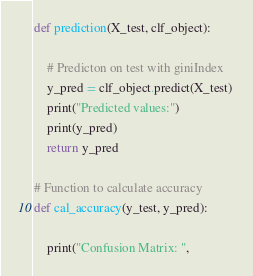<code> <loc_0><loc_0><loc_500><loc_500><_Python_>def prediction(X_test, clf_object): 

	# Predicton on test with giniIndex 
	y_pred = clf_object.predict(X_test) 
	print("Predicted values:") 
	print(y_pred) 
	return y_pred 
	
# Function to calculate accuracy 
def cal_accuracy(y_test, y_pred): 
	
	print("Confusion Matrix: ", </code> 